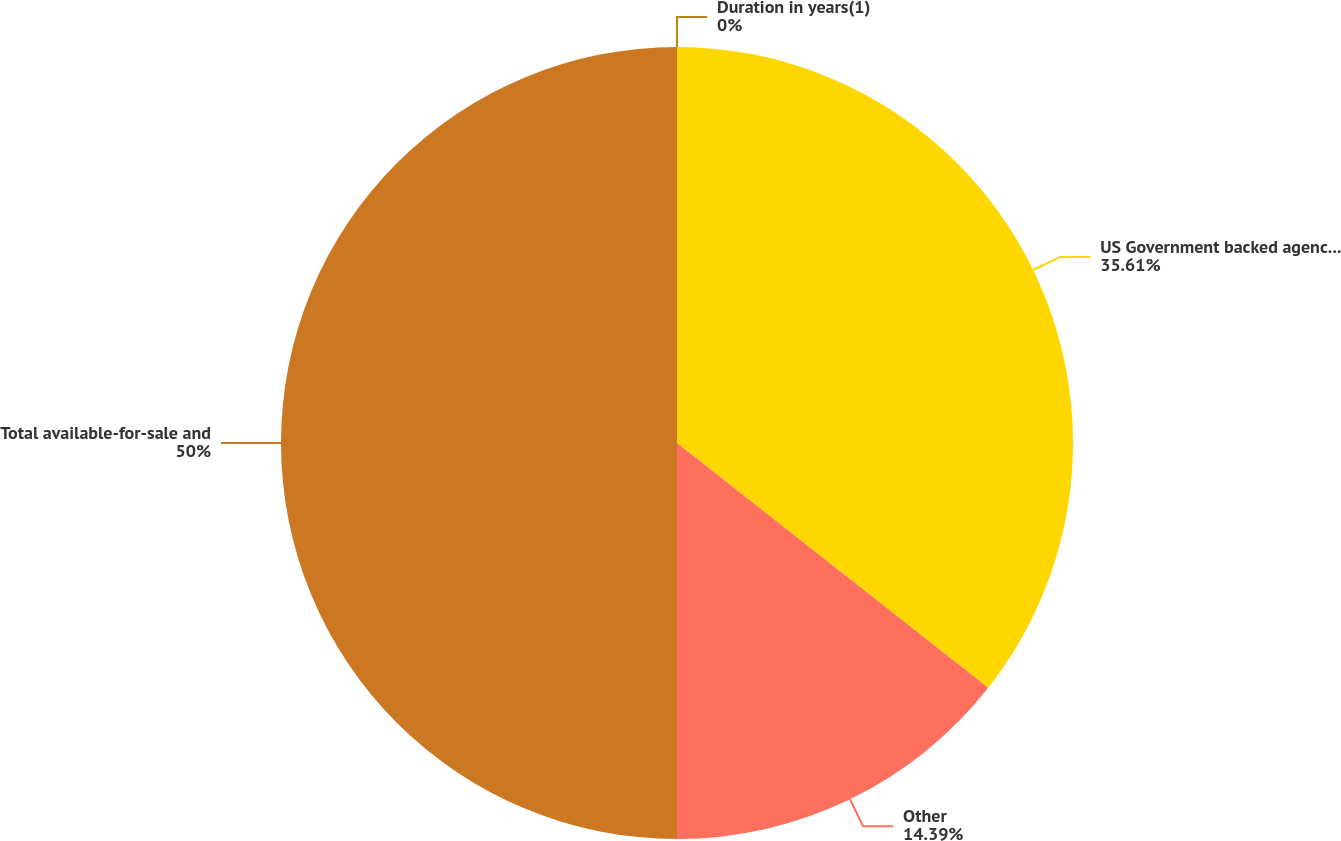Convert chart to OTSL. <chart><loc_0><loc_0><loc_500><loc_500><pie_chart><fcel>US Government backed agencies<fcel>Other<fcel>Total available-for-sale and<fcel>Duration in years(1)<nl><fcel>35.61%<fcel>14.39%<fcel>50.0%<fcel>0.0%<nl></chart> 